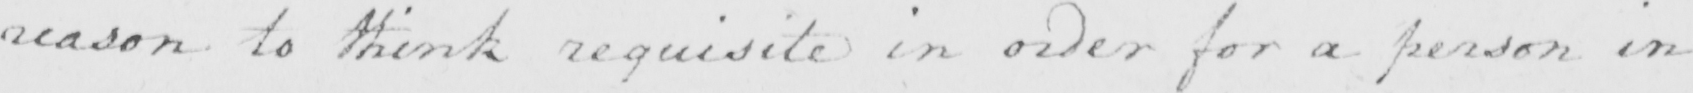Can you read and transcribe this handwriting? reason to think requisite in order for a person in 